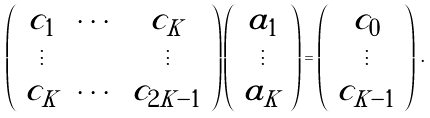Convert formula to latex. <formula><loc_0><loc_0><loc_500><loc_500>\left ( \begin{array} { c c c } c _ { 1 } & \cdots & c _ { K } \\ \vdots & & \vdots \\ c _ { K } & \cdots & c _ { 2 K - 1 } \end{array} \right ) \left ( \begin{array} { c } a _ { 1 } \\ \vdots \\ a _ { K } \end{array} \right ) = \left ( \begin{array} { c } c _ { 0 } \\ \vdots \\ c _ { K - 1 } \end{array} \right ) \, .</formula> 